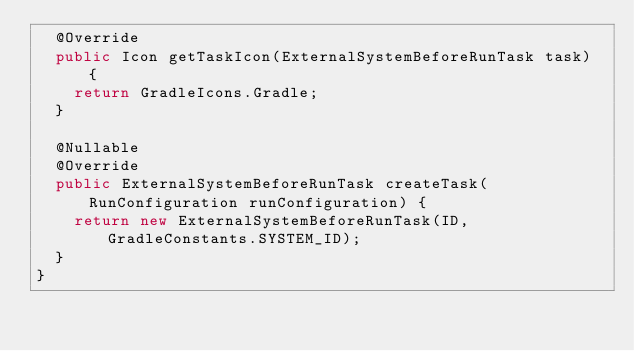Convert code to text. <code><loc_0><loc_0><loc_500><loc_500><_Java_>  @Override
  public Icon getTaskIcon(ExternalSystemBeforeRunTask task) {
    return GradleIcons.Gradle;
  }

  @Nullable
  @Override
  public ExternalSystemBeforeRunTask createTask(RunConfiguration runConfiguration) {
    return new ExternalSystemBeforeRunTask(ID, GradleConstants.SYSTEM_ID);
  }
}
</code> 